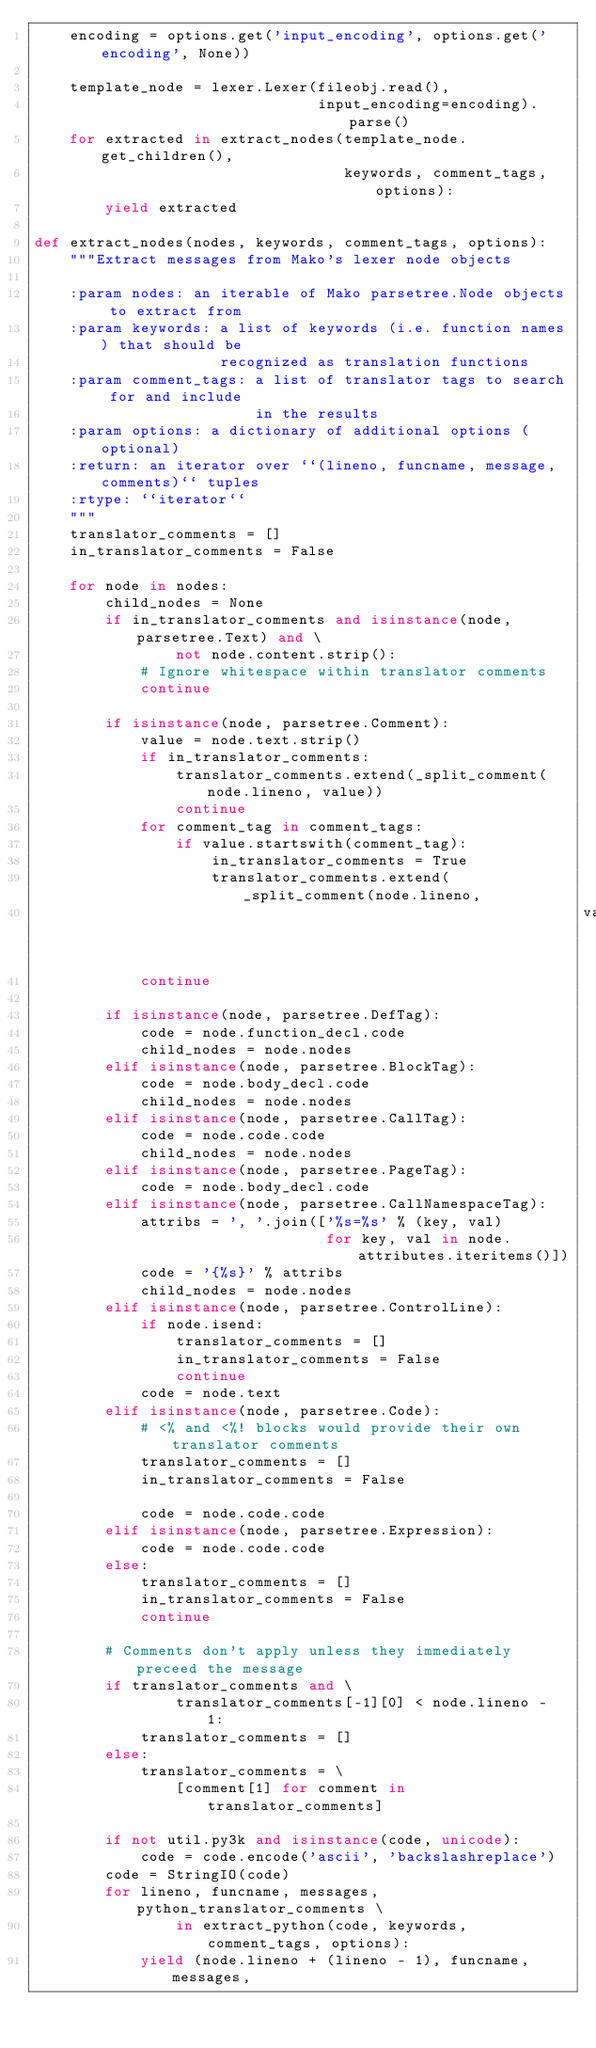<code> <loc_0><loc_0><loc_500><loc_500><_Python_>    encoding = options.get('input_encoding', options.get('encoding', None))

    template_node = lexer.Lexer(fileobj.read(),
                                input_encoding=encoding).parse()
    for extracted in extract_nodes(template_node.get_children(),
                                   keywords, comment_tags, options):
        yield extracted

def extract_nodes(nodes, keywords, comment_tags, options):
    """Extract messages from Mako's lexer node objects

    :param nodes: an iterable of Mako parsetree.Node objects to extract from
    :param keywords: a list of keywords (i.e. function names) that should be
                     recognized as translation functions
    :param comment_tags: a list of translator tags to search for and include
                         in the results
    :param options: a dictionary of additional options (optional)
    :return: an iterator over ``(lineno, funcname, message, comments)`` tuples
    :rtype: ``iterator``
    """
    translator_comments = []
    in_translator_comments = False

    for node in nodes:
        child_nodes = None
        if in_translator_comments and isinstance(node, parsetree.Text) and \
                not node.content.strip():
            # Ignore whitespace within translator comments
            continue

        if isinstance(node, parsetree.Comment):
            value = node.text.strip()
            if in_translator_comments:
                translator_comments.extend(_split_comment(node.lineno, value))
                continue
            for comment_tag in comment_tags:
                if value.startswith(comment_tag):
                    in_translator_comments = True
                    translator_comments.extend(_split_comment(node.lineno,
                                                              value))
            continue

        if isinstance(node, parsetree.DefTag):
            code = node.function_decl.code
            child_nodes = node.nodes
        elif isinstance(node, parsetree.BlockTag):
            code = node.body_decl.code
            child_nodes = node.nodes
        elif isinstance(node, parsetree.CallTag):
            code = node.code.code
            child_nodes = node.nodes
        elif isinstance(node, parsetree.PageTag):
            code = node.body_decl.code
        elif isinstance(node, parsetree.CallNamespaceTag):
            attribs = ', '.join(['%s=%s' % (key, val)
                                 for key, val in node.attributes.iteritems()])
            code = '{%s}' % attribs
            child_nodes = node.nodes
        elif isinstance(node, parsetree.ControlLine):
            if node.isend:
                translator_comments = []
                in_translator_comments = False
                continue
            code = node.text
        elif isinstance(node, parsetree.Code):
            # <% and <%! blocks would provide their own translator comments
            translator_comments = []
            in_translator_comments = False

            code = node.code.code
        elif isinstance(node, parsetree.Expression):
            code = node.code.code
        else:
            translator_comments = []
            in_translator_comments = False
            continue

        # Comments don't apply unless they immediately preceed the message
        if translator_comments and \
                translator_comments[-1][0] < node.lineno - 1:
            translator_comments = []
        else:
            translator_comments = \
                [comment[1] for comment in translator_comments]

        if not util.py3k and isinstance(code, unicode):
            code = code.encode('ascii', 'backslashreplace')
        code = StringIO(code)
        for lineno, funcname, messages, python_translator_comments \
                in extract_python(code, keywords, comment_tags, options):
            yield (node.lineno + (lineno - 1), funcname, messages,</code> 